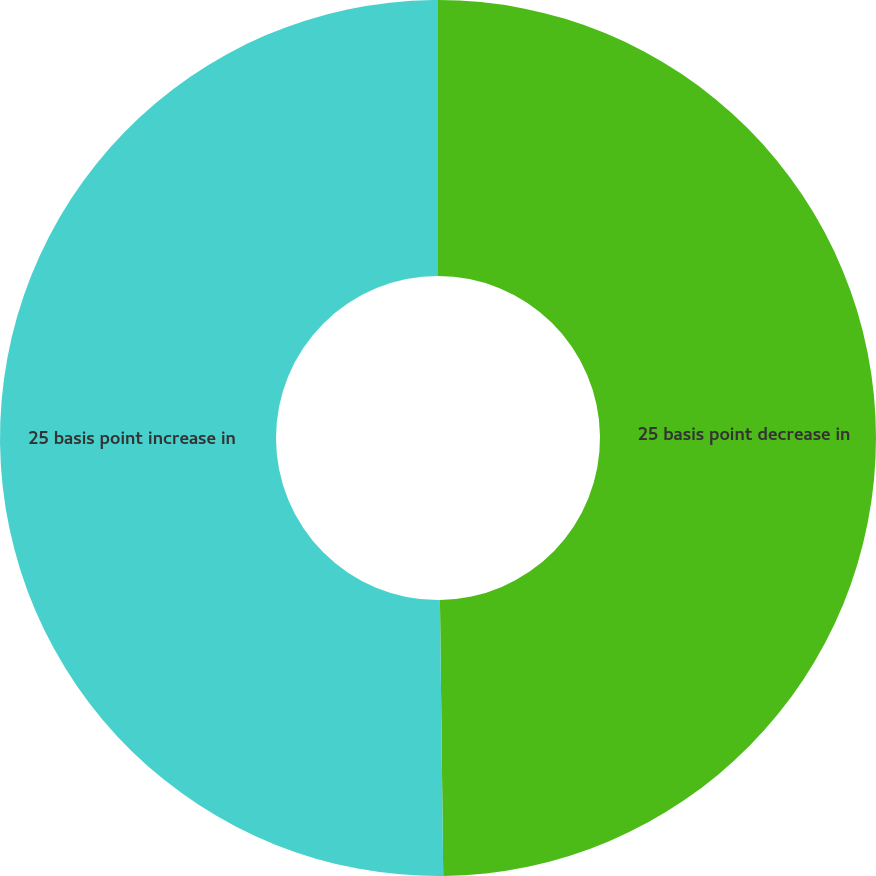<chart> <loc_0><loc_0><loc_500><loc_500><pie_chart><fcel>25 basis point decrease in<fcel>25 basis point increase in<nl><fcel>49.81%<fcel>50.19%<nl></chart> 